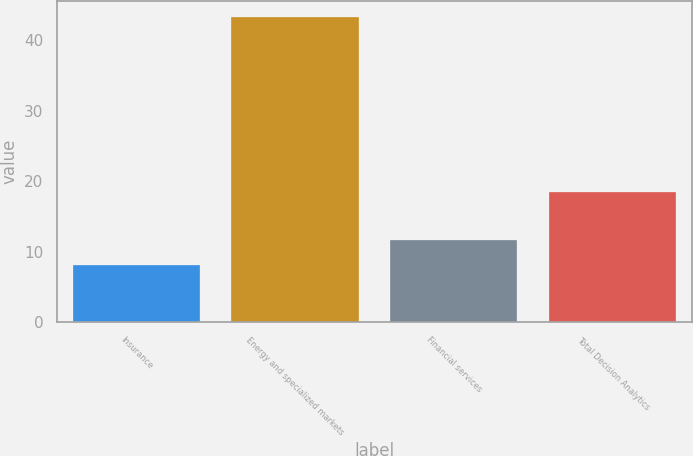Convert chart to OTSL. <chart><loc_0><loc_0><loc_500><loc_500><bar_chart><fcel>Insurance<fcel>Energy and specialized markets<fcel>Financial services<fcel>Total Decision Analytics<nl><fcel>8.1<fcel>43.4<fcel>11.63<fcel>18.5<nl></chart> 